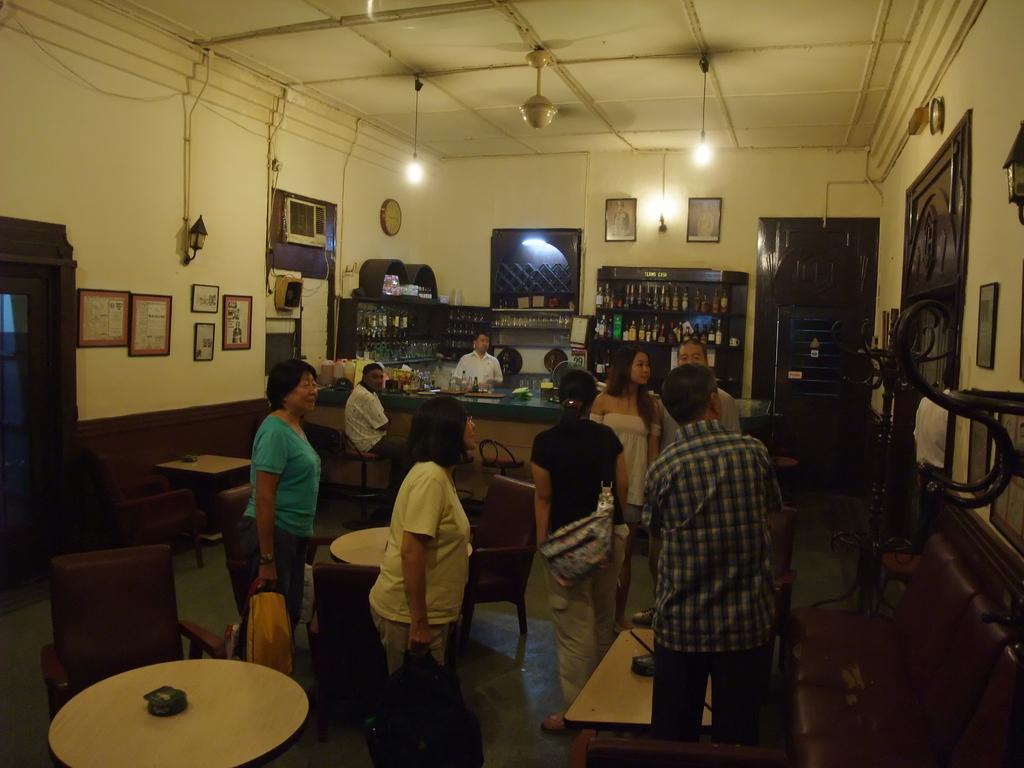Describe this image in one or two sentences. In the picture we can see a bar with a desk on it we can see some wine bottles and behind the desk we can see a man standing and behind him we can see racks with full of wine bottles and we can see tables and chairs, near it we can see some men and women are standing and watching something on the wall and to the ceiling we can see some lights and fan to the walls we can see some photo frames. 